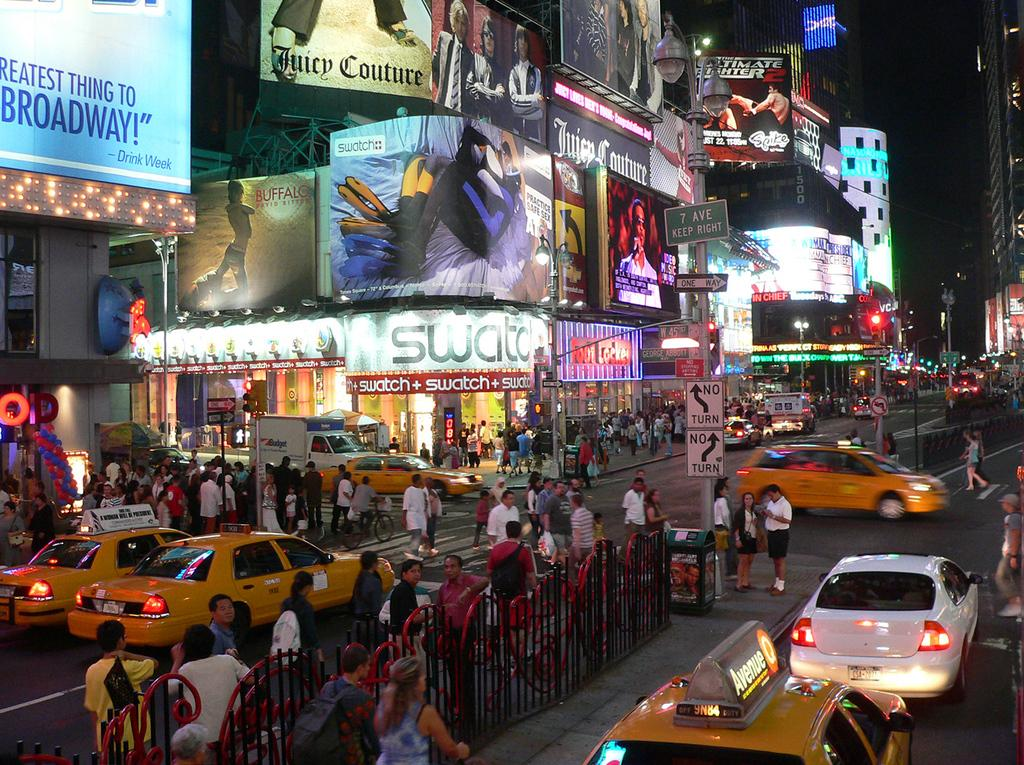<image>
Render a clear and concise summary of the photo. An NYC street sign announces that 7th Avenue is coming up on the right. 